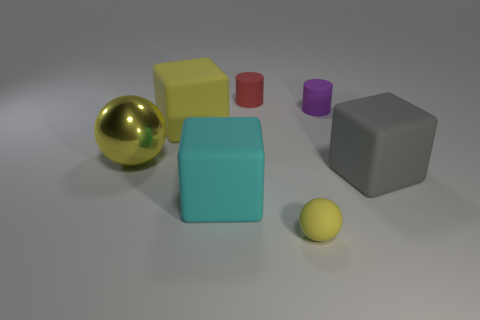Subtract all gray cubes. How many cubes are left? 2 Add 2 large brown objects. How many objects exist? 9 Subtract all red cylinders. How many cylinders are left? 1 Subtract all cubes. How many objects are left? 4 Subtract all yellow cylinders. Subtract all yellow blocks. How many cylinders are left? 2 Add 2 large cyan matte cubes. How many large cyan matte cubes are left? 3 Add 6 purple objects. How many purple objects exist? 7 Subtract 0 purple cubes. How many objects are left? 7 Subtract all tiny red rubber things. Subtract all tiny gray matte cylinders. How many objects are left? 6 